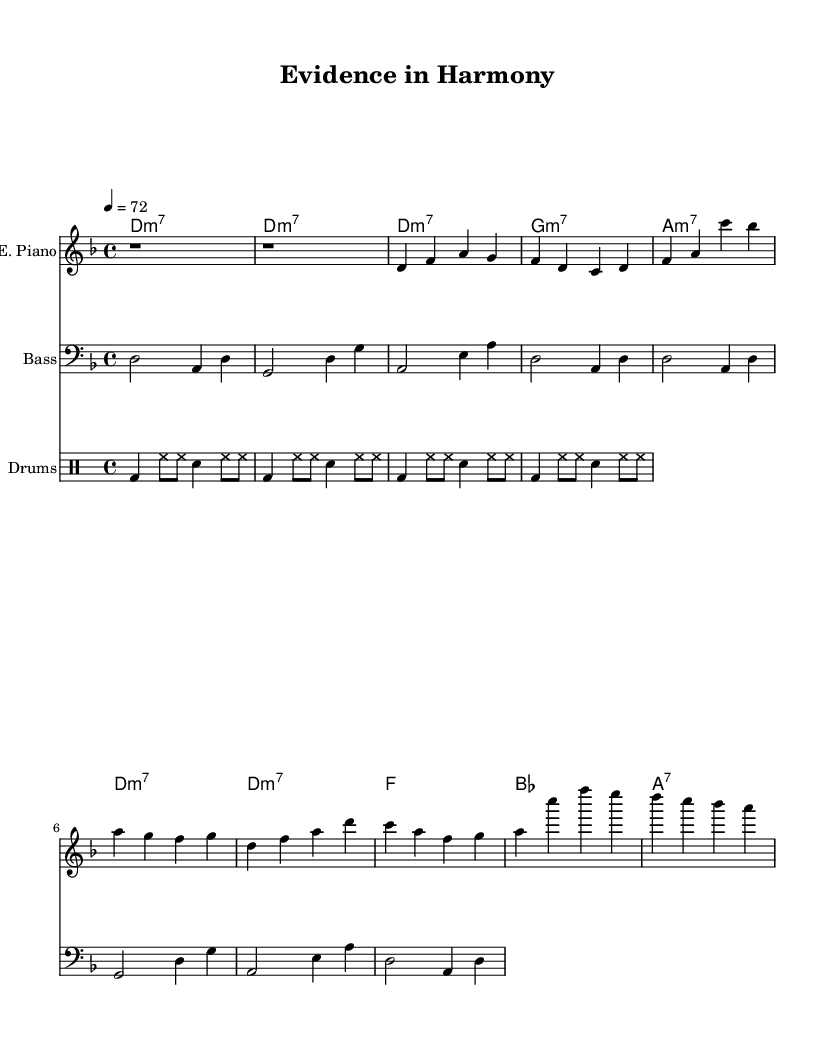What is the key signature of this music? The key signature is D minor, which has one flat (B flat). This can be determined by looking at the key signature at the beginning of the staff, where one flat is indicated.
Answer: D minor What is the time signature of this music? The time signature is 4/4, which is shown at the beginning of the score. This indicates that there are four beats in each measure and the quarter note gets one beat.
Answer: 4/4 What is the tempo marking for this piece? The tempo marking is 72 beats per minute, indicated at the beginning of the score. This means the piece should be played at a moderate pace, counting 72 quarter note beats in one minute.
Answer: 72 How many measures are in the chorus section? The chorus consists of four measures, which can be counted by looking at the musical notation in the chorus section of the sheet music.
Answer: 4 What is the instrument used for the main melody in this piece? The main melody is played on the electric piano, which is indicated on the staff heading as "E. Piano." Therefore, the electric piano is the primary instrument for the melody throughout the music.
Answer: Electric Piano What chords are used in the verse section? The verse section consists of three chords: D minor 7, G minor 7, and A minor 7. This can be deduced by examining the chord names above the respective measures in the verse area of the sheet music.
Answer: D minor 7, G minor 7, A minor 7 What type of groove is reflected in the drums part? The drums part shows a steady four-beat groove, characterized by bass drums, hi-hats, and snare. This groove aligns with common features found in soul music, emphasizing rhythm and syncopation.
Answer: Four-beat groove 